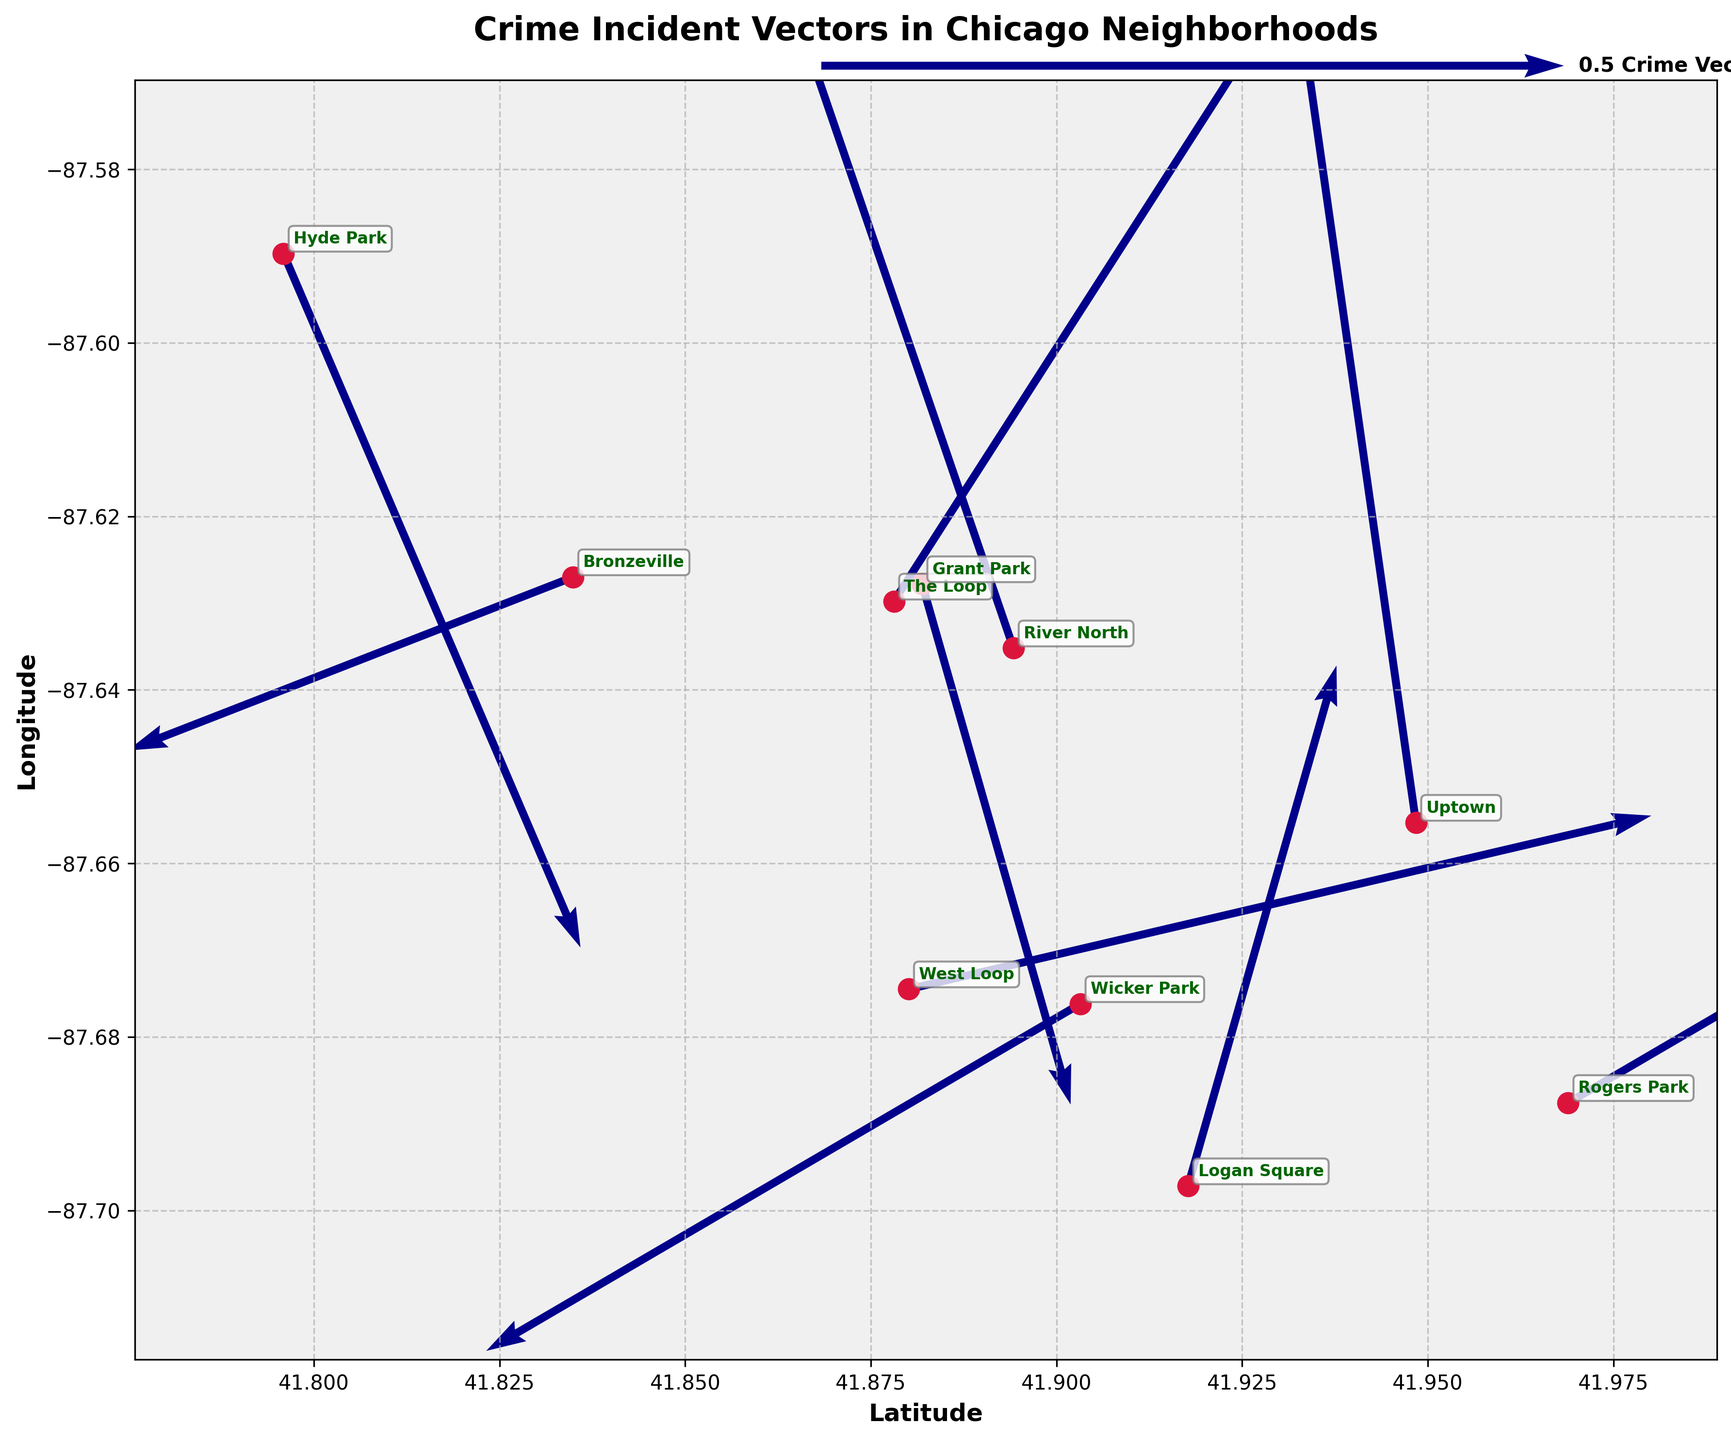What is the title of the plot? The title is usually located at the top of the plot. In this case, it reads "Crime Incident Vectors in Chicago Neighborhoods".
Answer: Crime Incident Vectors in Chicago Neighborhoods How many neighborhoods are displayed in the plot? By counting the annotated neighborhood names in the plot, we can determine the number of neighborhoods.
Answer: 10 Which neighborhood has the largest vector magnitude? To find the largest vector magnitude, identify the longest arrow in the plot. In this case, it's Uptown, with a (0.6,-0.1) vector.
Answer: Uptown Which direction is the crime vector pointing in River North? The crime vector in River North is denoted by an arrow, and we need to observe the arrow direction from the neighborhood's position. Based on the data (u=-0.2, v=0.5), it points northwest.
Answer: Northwest Which neighborhood vectors indicate a reduction in criminal activity? Reduction in criminal activity would likely be represented by vectors with a negative component. Observing the vectors, neighborhoods such as Wicker Park, Bronzeville, and River North display negativity in at least one direction.
Answer: Wicker Park, Bronzeville, River North Compare the direction of crime vectors between Grant Park and Hyde Park. By observing both arrows, we see the Grant Park vector (0.1, -0.3) points southeast, while the Hyde Park vector (0.2, -0.4) also points southeast. The directions are similar.
Answer: Similar (Southeast) What is the general trend of crime vectors in neighborhoods along the Northside compared to the Southside? Observing neighborhoods north of downtown (River North, Uptown, Rogers Park) and comparing them with those south (Hyde Park, Bronzeville), vectors in the Northside generally point upwards indicating an increase, while the Southside vectors point downwards indicating a decrease.
Answer: Northside: Increase, Southside: Decrease 